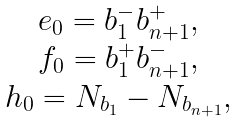<formula> <loc_0><loc_0><loc_500><loc_500>\begin{array} { c } e _ { 0 } = b _ { 1 } ^ { - } b _ { n + 1 } ^ { + } , \\ f _ { 0 } = b _ { 1 } ^ { + } b _ { n + 1 } ^ { - } , \\ h _ { 0 } = N _ { b _ { 1 } } - N _ { b _ { n + 1 } } , \end{array}</formula> 